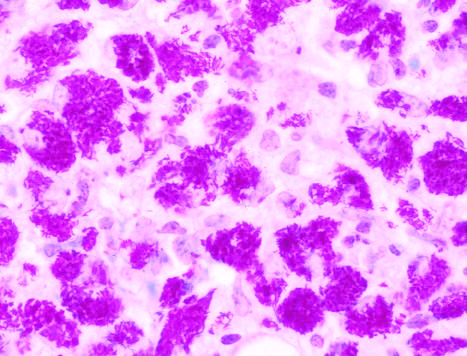what are seen in this specimen from an immunosuppressed patient?
Answer the question using a single word or phrase. Sheets of macrophages packed with mycobacteria 